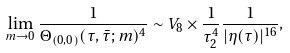Convert formula to latex. <formula><loc_0><loc_0><loc_500><loc_500>\lim _ { m \rightarrow 0 } \frac { 1 } { \Theta _ { ( 0 , 0 ) } ( \tau , \bar { \tau } ; m ) ^ { 4 } } \sim V _ { 8 } \times \frac { 1 } { \tau _ { 2 } ^ { 4 } } \frac { 1 } { | \eta ( \tau ) | ^ { 1 6 } } ,</formula> 